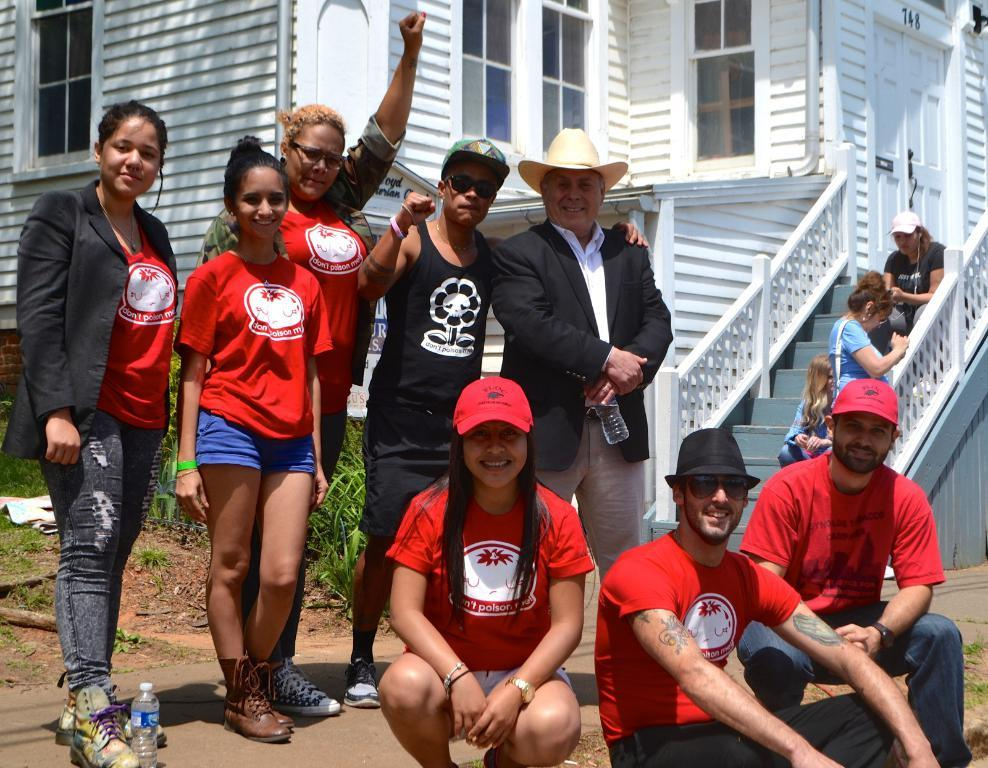What is the main subject in the foreground of the image? There is a group of people in the foreground of the image. What can be seen in the background of the image? There are plants and a house visible in the background of the image. What type of worm can be seen crawling on the house in the image? There is no worm present in the image; the house and plants are visible in the background, but no worms are mentioned in the facts. 